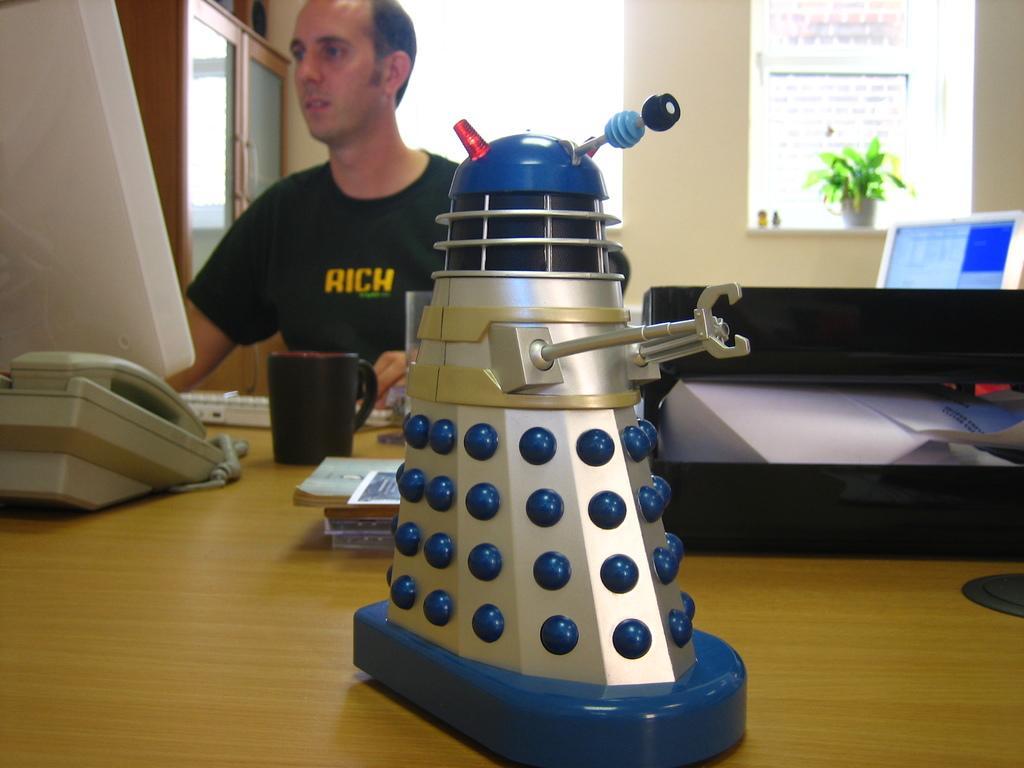In one or two sentences, can you explain what this image depicts? In the picture we can see a man sitting on the chair near the table, he is wearing a black T-shirt and on the table, we can see a monitor, behind it, we can see a telephone and besides it, we can see some fax machines and in the background we can see a wall and house plant on it and beside it we can see another monitor screen. 